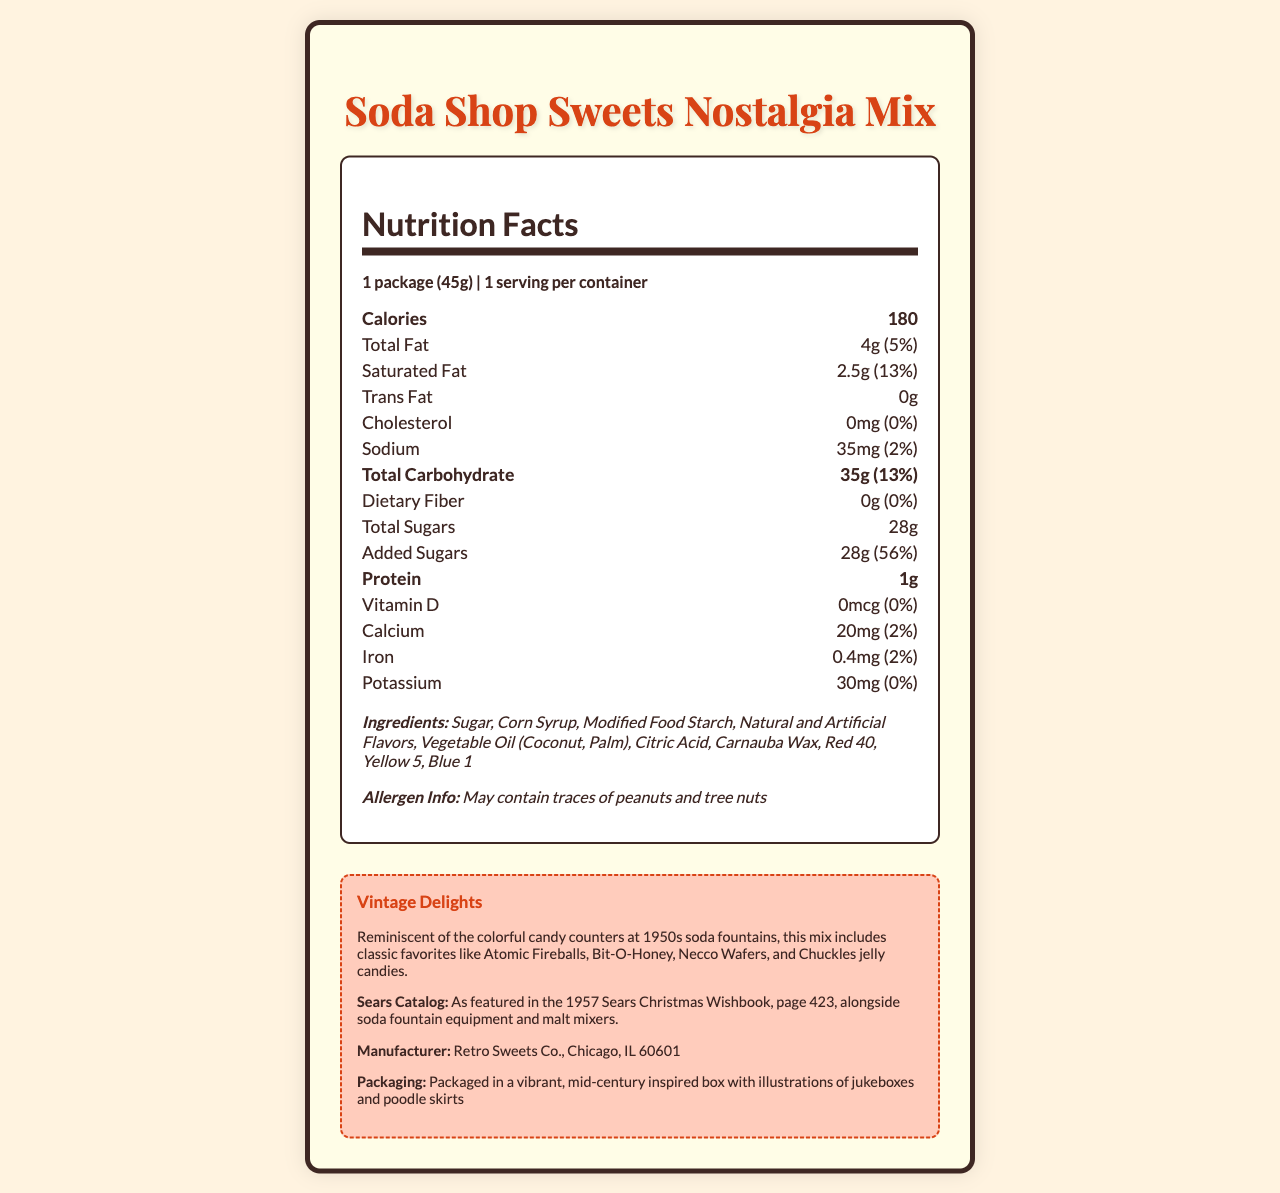what is the serving size? The serving size is listed at the beginning of the Nutrition Facts as "1 package (45g)".
Answer: 1 package (45g) how many calories are in one serving? The calories per serving is shown under the Calories header as "180".
Answer: 180 what is the total fat percentage daily value? The daily value percentage for Total Fat is listed as "5%" next to the total fat amount.
Answer: 5% how much added sugar is in the candy mix? Under the nutrition item for Added Sugars, the amount is listed as "28g".
Answer: 28g which ingredient is listed first? Ingredients are listed in order of quantity, and Sugar is the first item in the Ingredients list.
Answer: Sugar is there any dietary fiber in this product? According to the Nutrition Facts, the amount of Dietary Fiber is "0g", indicating there is none.
Answer: No which vitamins or minerals are included in the Nutrition Facts? A. Vitamin D, Calcium, Iron, Potassium B. Vitamin A, Vitamin C C. Folic Acid, Biotin The Nutrition Facts list Vitamin D, Calcium, Iron, and Potassium.
Answer: A what is the nostalgic description of this candy mix? A. Includes classic favorites like Atomic Fireballs, Bit-O-Honey, Necco Wafers, and Chuckles. B. Includes retro favorites like Hershey bars, Snickers, and Skittles. C. Includes old-fashioned delights like caramel popcorn and cotton candy. The Vintage Delights section describes the candy mix as including Atomic Fireballs, Bit-O-Honey, Necco Wafers, and Chuckles.
Answer: A does the product contain peanuts? The allergen info states that the product may contain traces of peanuts and tree nuts.
Answer: May contain traces describe the packaging style of the Soda Shop Sweets Nostalgia Mix. The packaging description is provided in the vintage info section, indicating the style of the packaging.
Answer: Packaged in a vibrant, mid-century inspired box with illustrations of jukeboxes and poodle skirts does the document mention the exact year when this candy mix was featured in the Sears catalog? The vintage description references the 1957 Sears Christmas Wishbook.
Answer: Yes who is the manufacturer of this product? The manufacturer is listed in the vintage info section under the Manufacturer heading as Retro Sweets Co.
Answer: Retro Sweets Co., Chicago, IL 60601 summarize the main idea of the document. The document is structured to give comprehensive information on the nutritional value and historical context of the candy mix, highlighting its retro appeal and packaging style.
Answer: The document provides a detailed overview of the nutritional information for the Soda Shop Sweets Nostalgia Mix, including serving size, calories, and nutrient contents. It also presents additional details such as ingredients, allergen information, and a nostalgic description linking the candy to mid-century soda fountains and a 1957 Sears catalog reference. what is the exact amount of Vitamin C in the candy mix? The document does not list Vitamin C in the Nutrition Facts, so the amount is not provided.
Answer: Cannot be determined 